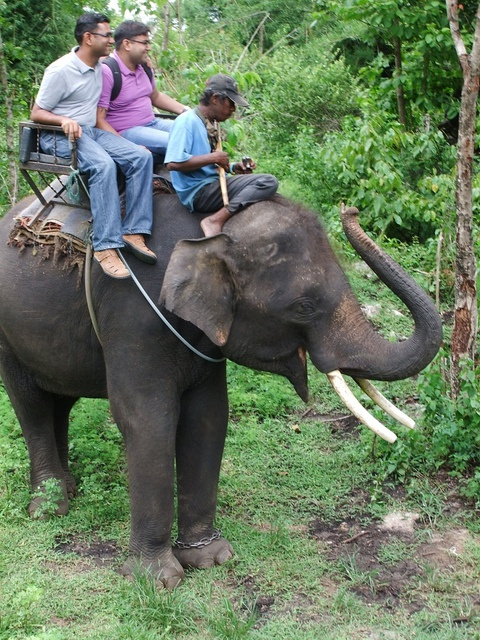Describe the objects in this image and their specific colors. I can see elephant in lightgreen, gray, black, and darkgray tones, people in lightgreen, lavender, darkgray, and gray tones, people in lightgreen, black, gray, darkgray, and lightblue tones, people in lightgreen, violet, gray, and lavender tones, and bench in lightgreen, gray, black, and darkgray tones in this image. 